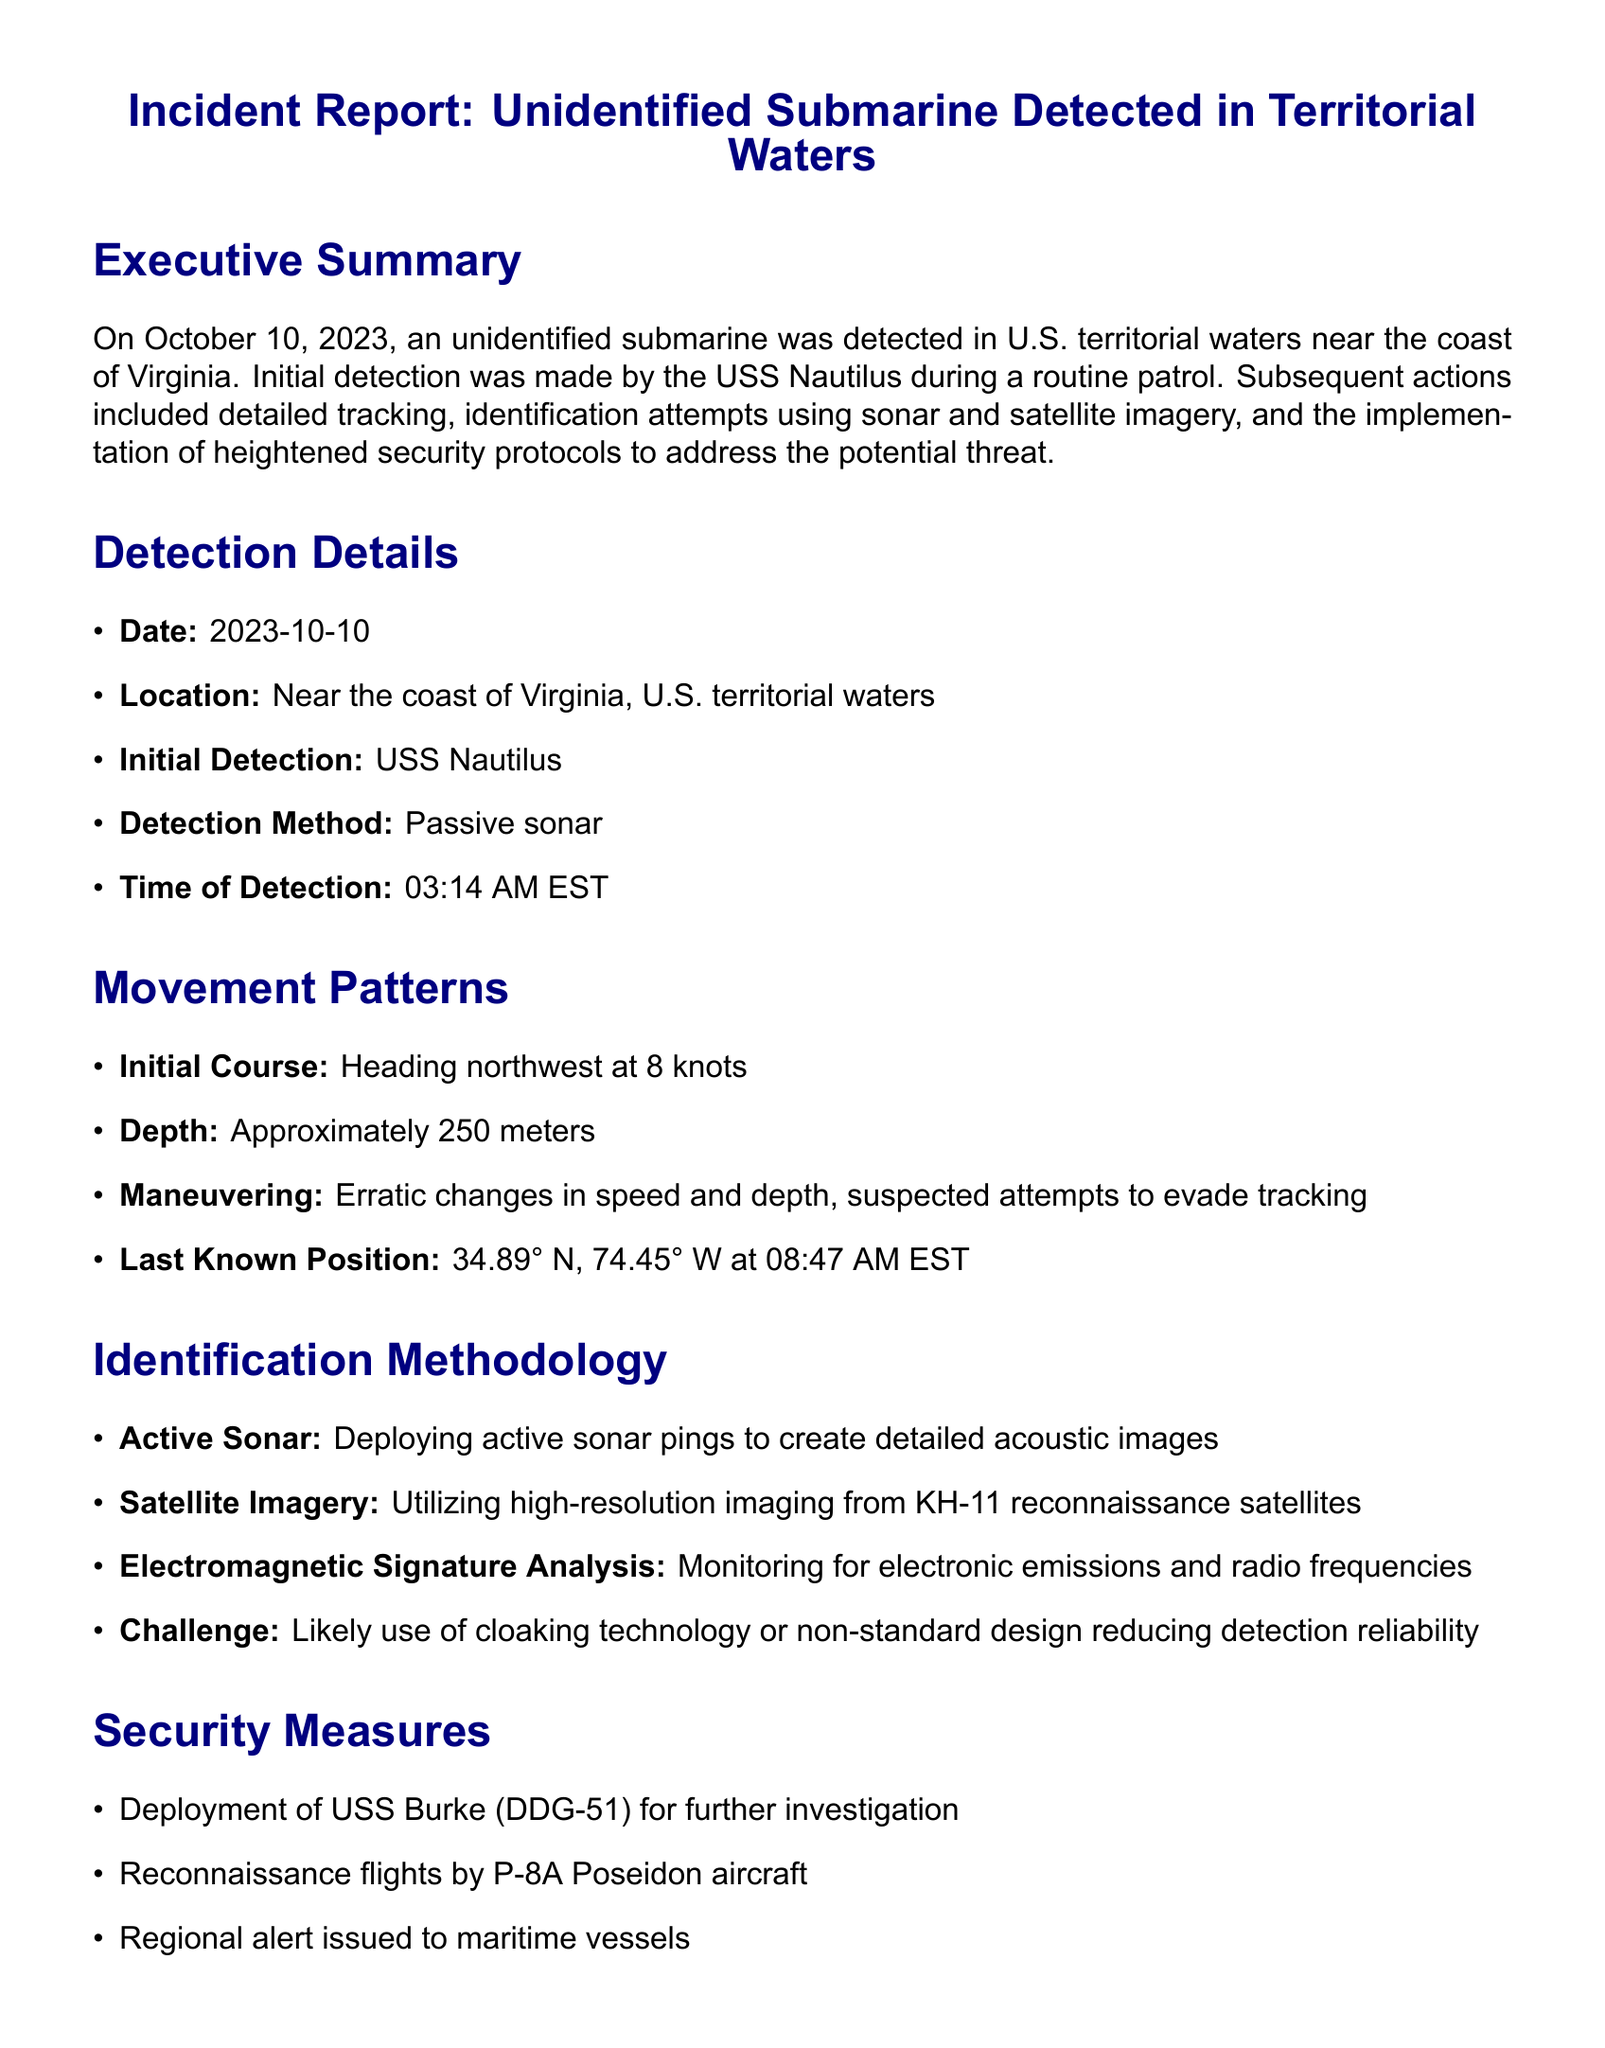what was the date of the incident? The date of the incident is explicitly stated in the document as October 10, 2023.
Answer: October 10, 2023 who made the initial detection? The document specifies that the initial detection was made by the USS Nautilus.
Answer: USS Nautilus what was the depth of the unidentified submarine? The document mentions that the submarine was at a depth of approximately 250 meters.
Answer: 250 meters what security measures were implemented? The document lists several security measures including deployment of USS Burke, reconnaissance flights, and regional vessel alerts.
Answer: Deployment of USS Burke (DDG-51) what was the presumed course of the unidentified submarine? The document describes the initial course of the submarine as heading northwest at 8 knots.
Answer: northwest at 8 knots what challenge was encountered during the identification process? The document states that a challenge faced was the likely use of cloaking technology or non-standard design.
Answer: cloaking technology what is the last known position of the unidentified submarine? The document provides the last known position as coordinates: 34.89° N, 74.45° W.
Answer: 34.89° N, 74.45° W what type of aircraft was used for reconnaissance? The document mentions the use of P-8A Poseidon aircraft for reconnaissance flights.
Answer: P-8A Poseidon what was the time of detection? The document specifies the time of detection as 03:14 AM EST.
Answer: 03:14 AM EST 